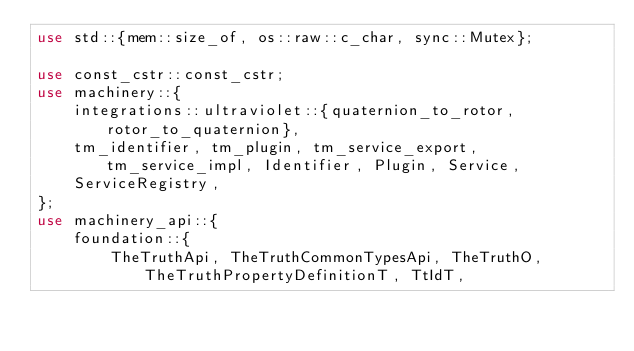Convert code to text. <code><loc_0><loc_0><loc_500><loc_500><_Rust_>use std::{mem::size_of, os::raw::c_char, sync::Mutex};

use const_cstr::const_cstr;
use machinery::{
    integrations::ultraviolet::{quaternion_to_rotor, rotor_to_quaternion},
    tm_identifier, tm_plugin, tm_service_export, tm_service_impl, Identifier, Plugin, Service,
    ServiceRegistry,
};
use machinery_api::{
    foundation::{
        TheTruthApi, TheTruthCommonTypesApi, TheTruthO, TheTruthPropertyDefinitionT, TtIdT,</code> 